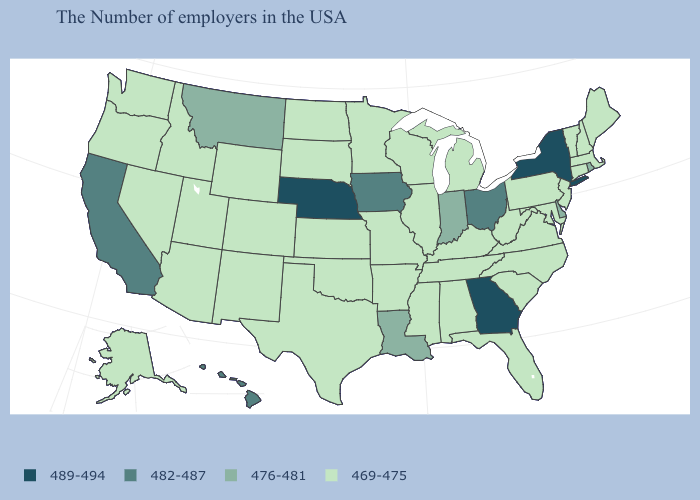Which states have the lowest value in the West?
Write a very short answer. Wyoming, Colorado, New Mexico, Utah, Arizona, Idaho, Nevada, Washington, Oregon, Alaska. Name the states that have a value in the range 476-481?
Concise answer only. Rhode Island, Delaware, Indiana, Louisiana, Montana. How many symbols are there in the legend?
Answer briefly. 4. What is the value of New Hampshire?
Concise answer only. 469-475. Among the states that border Texas , which have the highest value?
Concise answer only. Louisiana. What is the value of Vermont?
Be succinct. 469-475. Does the first symbol in the legend represent the smallest category?
Short answer required. No. Does Illinois have the lowest value in the MidWest?
Concise answer only. Yes. Name the states that have a value in the range 489-494?
Write a very short answer. New York, Georgia, Nebraska. Does Wyoming have the lowest value in the USA?
Give a very brief answer. Yes. Does the map have missing data?
Keep it brief. No. What is the value of Utah?
Short answer required. 469-475. What is the value of Oklahoma?
Concise answer only. 469-475. Does Delaware have a higher value than Alaska?
Keep it brief. Yes. 